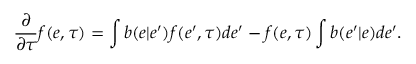Convert formula to latex. <formula><loc_0><loc_0><loc_500><loc_500>\frac { \partial } { \partial \tau } f ( e , \tau ) = \int b ( e | e ^ { \prime } ) f ( e ^ { \prime } , \tau ) d e ^ { \prime } - f ( e , \tau ) \int b ( e ^ { \prime } | e ) d e ^ { \prime } .</formula> 